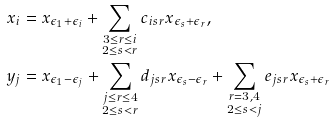Convert formula to latex. <formula><loc_0><loc_0><loc_500><loc_500>x _ { i } & = x _ { \epsilon _ { 1 } + \epsilon _ { i } } + \sum _ { \substack { 3 \leq r \leq i \\ 2 \leq s < r } } c _ { i s r } x _ { \epsilon _ { s } + \epsilon _ { r } } , \\ y _ { j } & = x _ { \epsilon _ { 1 } - \epsilon _ { j } } + \sum _ { \substack { j \leq r \leq 4 \\ 2 \leq s < r } } d _ { j s r } x _ { \epsilon _ { s } - \epsilon _ { r } } + \sum _ { \substack { r = 3 , 4 \\ 2 \leq s < j } } e _ { j s r } x _ { \epsilon _ { s } + \epsilon _ { r } }</formula> 